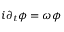<formula> <loc_0><loc_0><loc_500><loc_500>i \partial _ { t } \phi = \omega \phi</formula> 